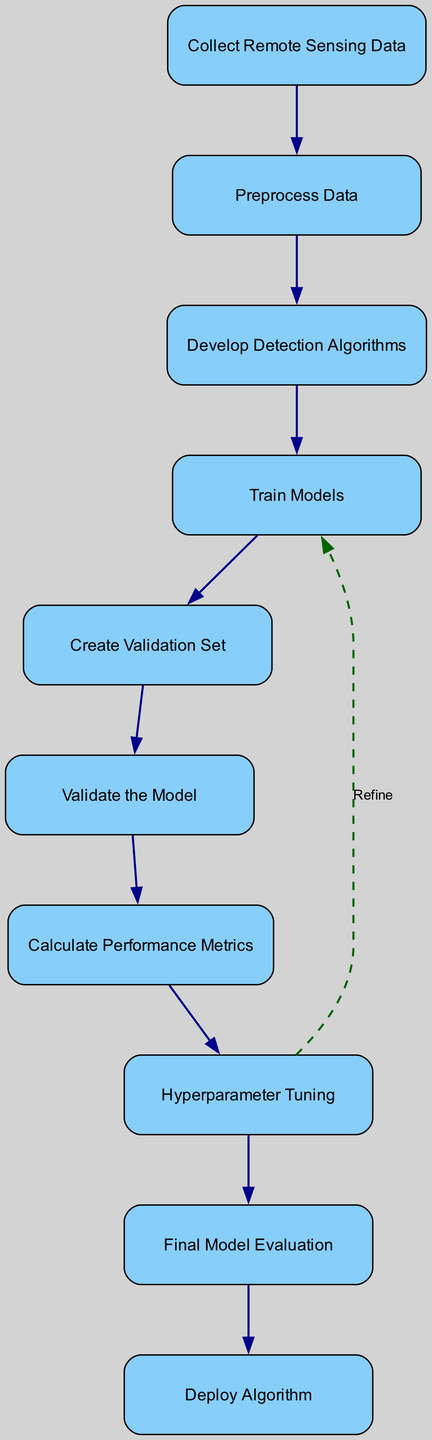What is the first step in the flow chart? The first step listed in the flow chart is "Collect Remote Sensing Data." It appears as the initial node, indicating that this is the starting point of the process.
Answer: Collect Remote Sensing Data How many nodes are there in the flow chart? By counting the distinct labeled rectangles in the flow chart, we find there are ten nodes representing different steps in the validation and evaluation process.
Answer: Ten What is the last step in the flow chart? The last node in the flow chart is "Deploy Algorithm." This is the final step after all previous evaluations and validations have been completed.
Answer: Deploy Algorithm What is the relationship between "Hyperparameter Tuning" and "Train Models"? The edge labeled "Refine" connecting "Hyperparameter Tuning" and "Train Models" indicates that after tuning, the training process is revisited to improve the model.
Answer: Refine What performance metrics are calculated after model validation? The flow chart specifies that several performance metrics—F1 Score, Precision, Recall, and AUC-ROC—are calculated to quantify the model's performance.
Answer: F1 Score, Precision, Recall, AUC-ROC What step directly follows "Train Models"? "Create Validation Set" follows "Train Models" in the sequence, indicating a logical progression to ensure model evaluation is unbiased.
Answer: Create Validation Set How many edges are there connecting the nodes in the chart? The edges represent the connections between nodes. There are nine connectors that direct from one step to the next, plus one additional feedback edge. After counting, there are ten edges in total.
Answer: Ten What is the purpose of the "Validation Set"? The diagram indicates the purpose of the "Validation Set" as ensuring unbiased evaluation of model performance, which is crucial for accurate predictions.
Answer: Unbiased evaluation Which step comes after "Calculate Performance Metrics"? Following "Calculate Performance Metrics," the next step is "Hyperparameter Tuning," emphasizing the iterative nature of improving the model based on performance results.
Answer: Hyperparameter Tuning What action occurs between "Model Validation" and "Calculate Performance Metrics"? After validating the model, the next logical action is to "Calculate Performance Metrics," effectively assessing the model's prediction quality.
Answer: Calculate Performance Metrics 